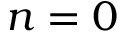Convert formula to latex. <formula><loc_0><loc_0><loc_500><loc_500>n = 0</formula> 